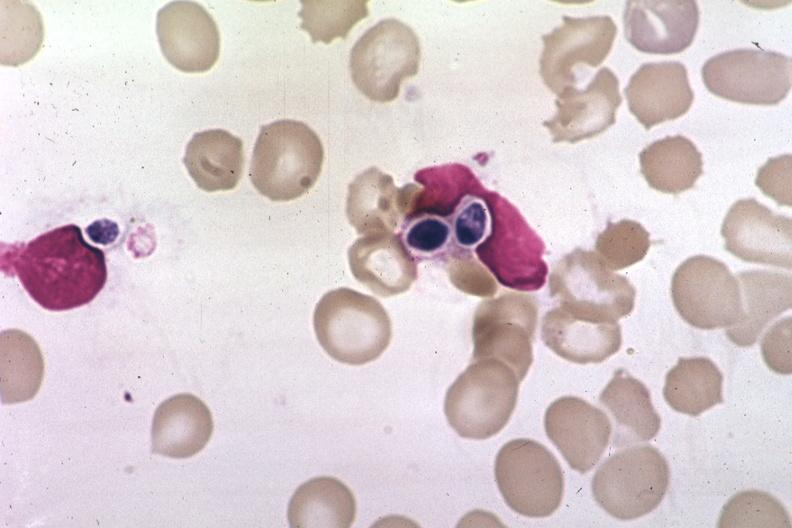s abdomen present?
Answer the question using a single word or phrase. No 